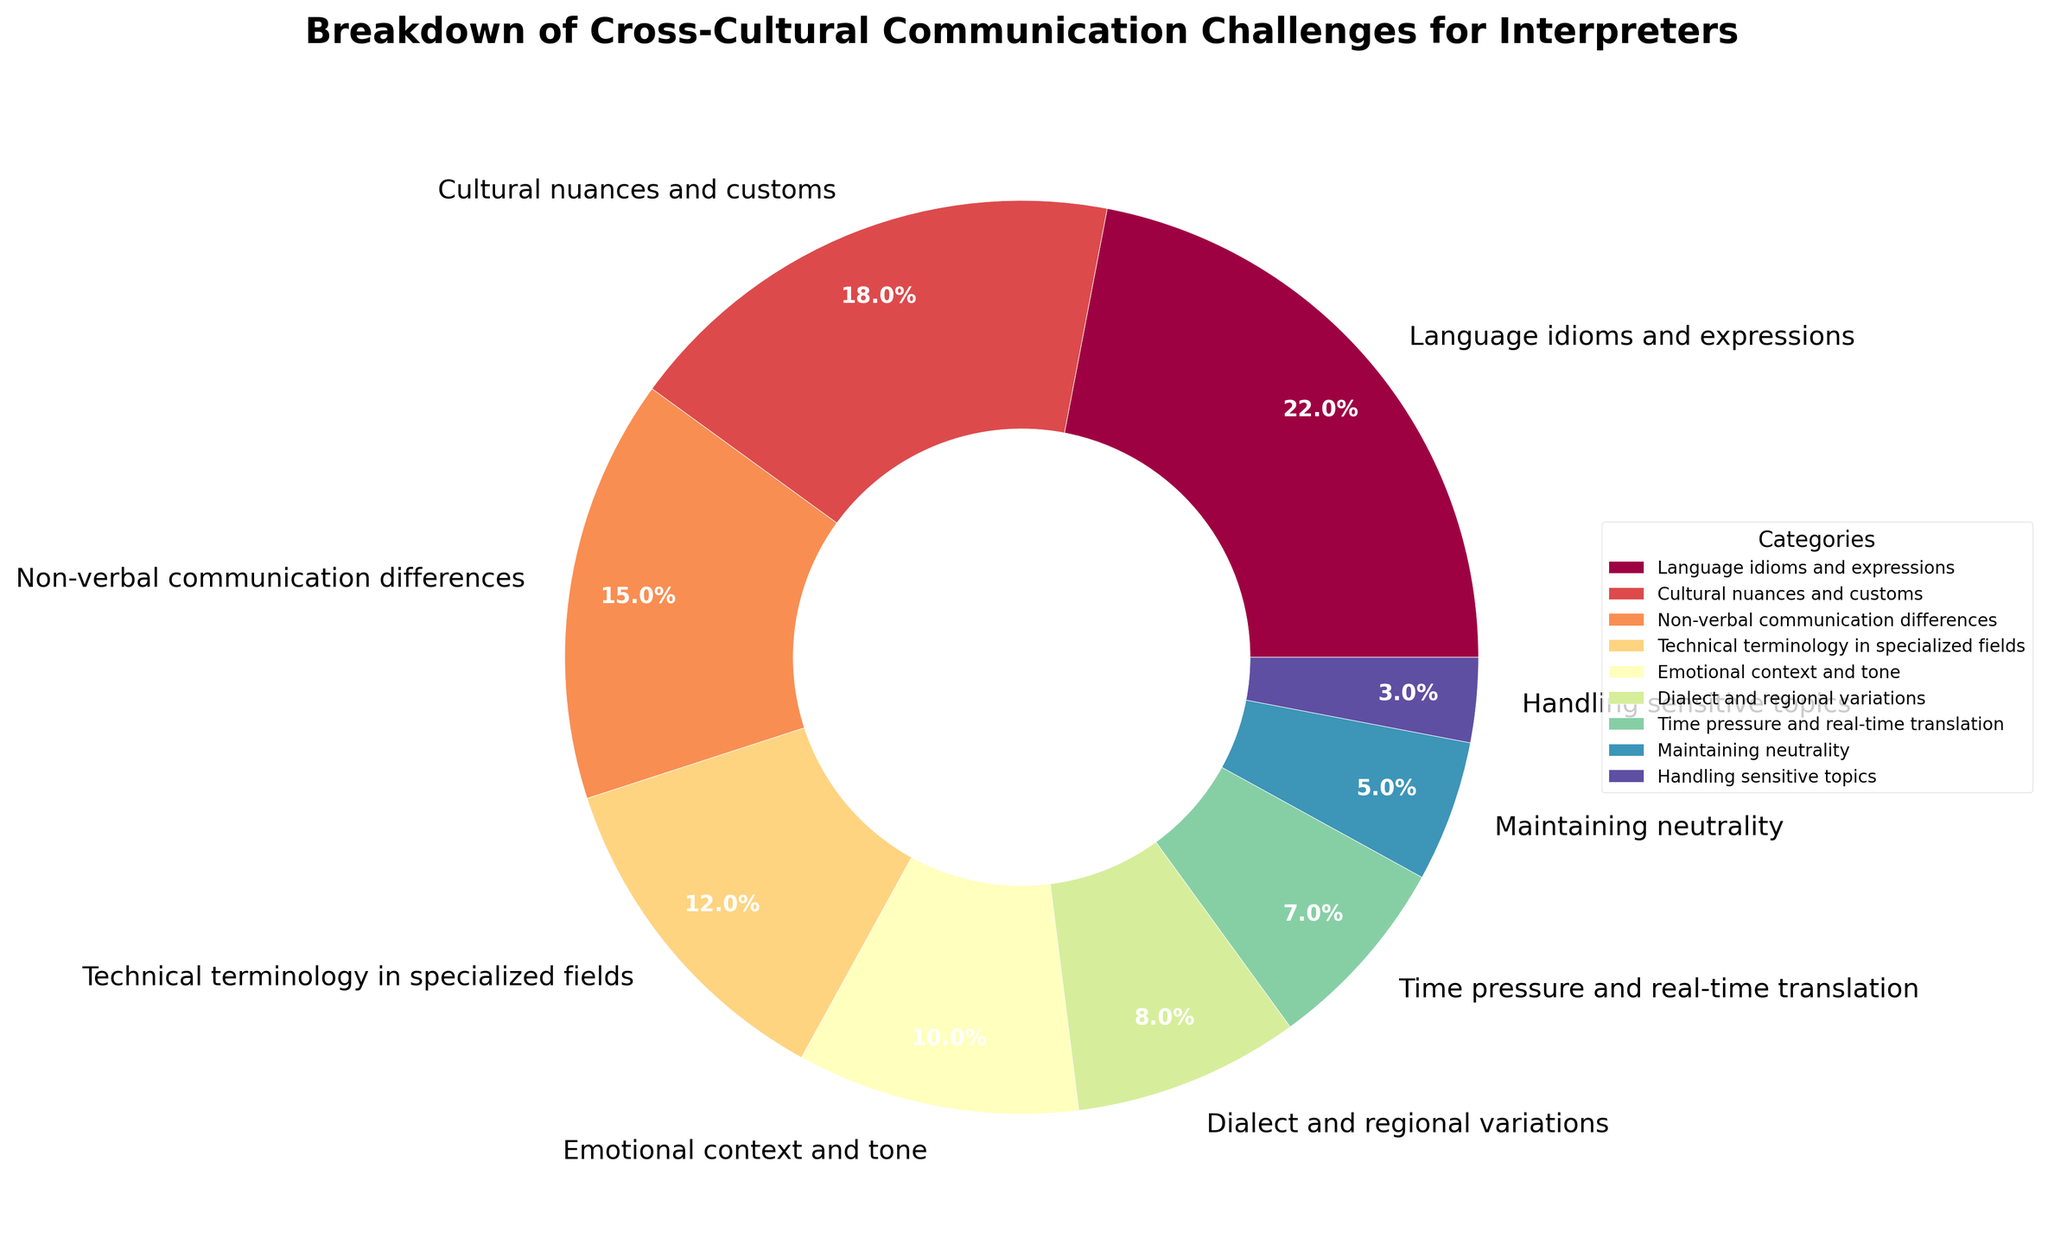Which category has the highest percentage in cross-cultural communication challenges for interpreters? To identify the highest percentage, look for the category with the largest pie slice. The label "Language idioms and expressions" shows 22%, which is the highest value.
Answer: Language idioms and expressions What is the combined percentage of challenges related to technical terminology and time pressure? Sum the percentages of "Technical terminology in specialized fields" (12%) and "Time pressure and real-time translation" (7%). 12% + 7% = 19%.
Answer: 19% How much greater is the percentage of cultural nuances and customs compared to dialect and regional variations? Subtract the percentage of "Dialect and regional variations" (8%) from "Cultural nuances and customs" (18%). 18% - 8% = 10%.
Answer: 10% Which category has the smallest percentage, and what is its value? Identify the category with the smallest pie slice. The label "Handling sensitive topics" shows 3%, which is the smallest value.
Answer: Handling sensitive topics, 3% What is the difference between the percentages of non-verbal communication differences and maintaining neutrality? Subtract the percentage of "Maintaining neutrality" (5%) from "Non-verbal communication differences" (15%). 15% - 5% = 10%.
Answer: 10% How does the percentage of emotional context and tone compare to the percentage of dialect and regional variations? Compare the values of "Emotional context and tone" (10%) and "Dialect and regional variations" (8%). 10% is greater than 8%.
Answer: Greater What is the combined percentage of the top three challenges? Sum the top three percentages: "Language idioms and expressions" (22%), "Cultural nuances and customs" (18%), and "Non-verbal communication differences" (15%). 22% + 18% + 15% = 55%.
Answer: 55% What is the average percentage of the categories which are above 10%? Identify the categories above 10%, then find the average: "Language idioms and expressions" (22%), "Cultural nuances and customs" (18%), "Non-verbal communication differences" (15%), and "Emotional context and tone" (10%). Calculate the sum (22% + 18% + 15% + 10% = 65%) and divide by the number of categories (4). 65% / 4 = 16.25%.
Answer: 16.25% Which categories have a percentage of 10% or less? Identify the categories with percentages 10% or lower: "Emotional context and tone" (10%), "Dialect and regional variations" (8%), "Time pressure and real-time translation" (7%), "Maintaining neutrality" (5%), and "Handling sensitive topics" (3%).
Answer: Emotional context and tone, Dialect and regional variations, Time pressure and real-time translation, Maintaining neutrality, Handling sensitive topics If an interpreter can manage all but two of these challenges, which two challenges would leave them with the least percentage of difficulty? To find the least challenging pair, identify the two categories with the smallest percentages: "Handling sensitive topics" (3%) and "Maintaining neutrality" (5%). Sum their percentages: 3% + 5% = 8%.
Answer: Handling sensitive topics and Maintaining neutrality 